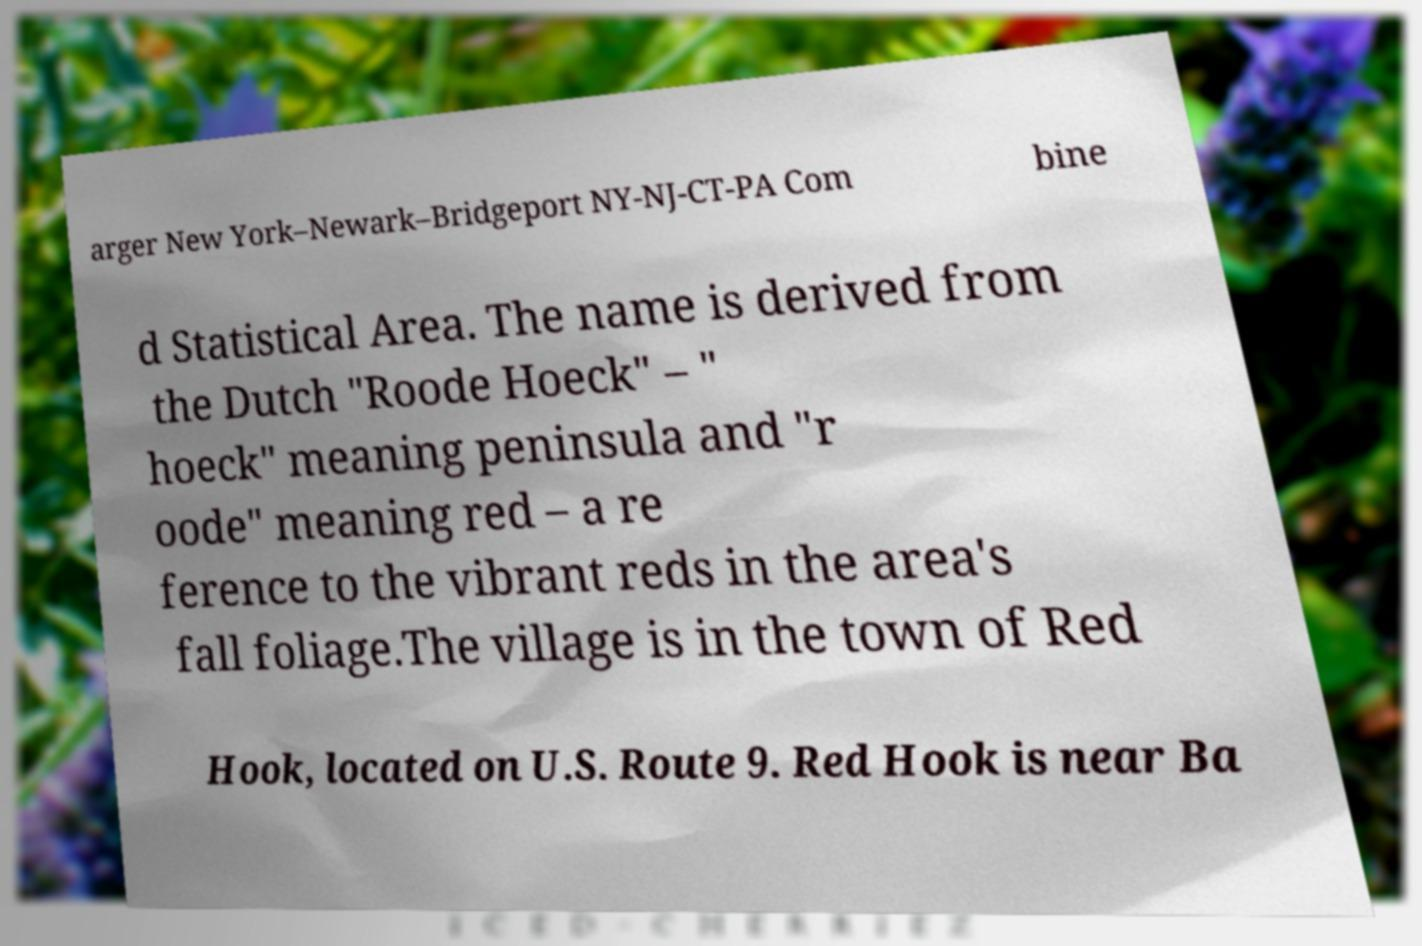Can you read and provide the text displayed in the image?This photo seems to have some interesting text. Can you extract and type it out for me? arger New York–Newark–Bridgeport NY-NJ-CT-PA Com bine d Statistical Area. The name is derived from the Dutch "Roode Hoeck" – " hoeck" meaning peninsula and "r oode" meaning red – a re ference to the vibrant reds in the area's fall foliage.The village is in the town of Red Hook, located on U.S. Route 9. Red Hook is near Ba 